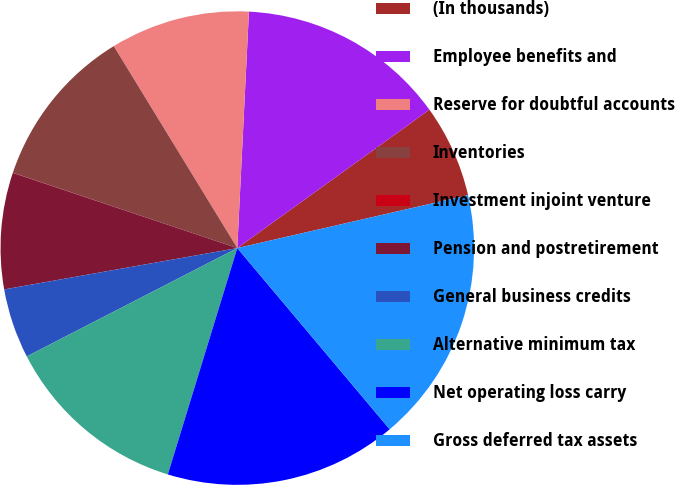Convert chart to OTSL. <chart><loc_0><loc_0><loc_500><loc_500><pie_chart><fcel>(In thousands)<fcel>Employee benefits and<fcel>Reserve for doubtful accounts<fcel>Inventories<fcel>Investment injoint venture<fcel>Pension and postretirement<fcel>General business credits<fcel>Alternative minimum tax<fcel>Net operating loss carry<fcel>Gross deferred tax assets<nl><fcel>6.35%<fcel>14.28%<fcel>9.52%<fcel>11.11%<fcel>0.01%<fcel>7.94%<fcel>4.77%<fcel>12.7%<fcel>15.87%<fcel>17.46%<nl></chart> 